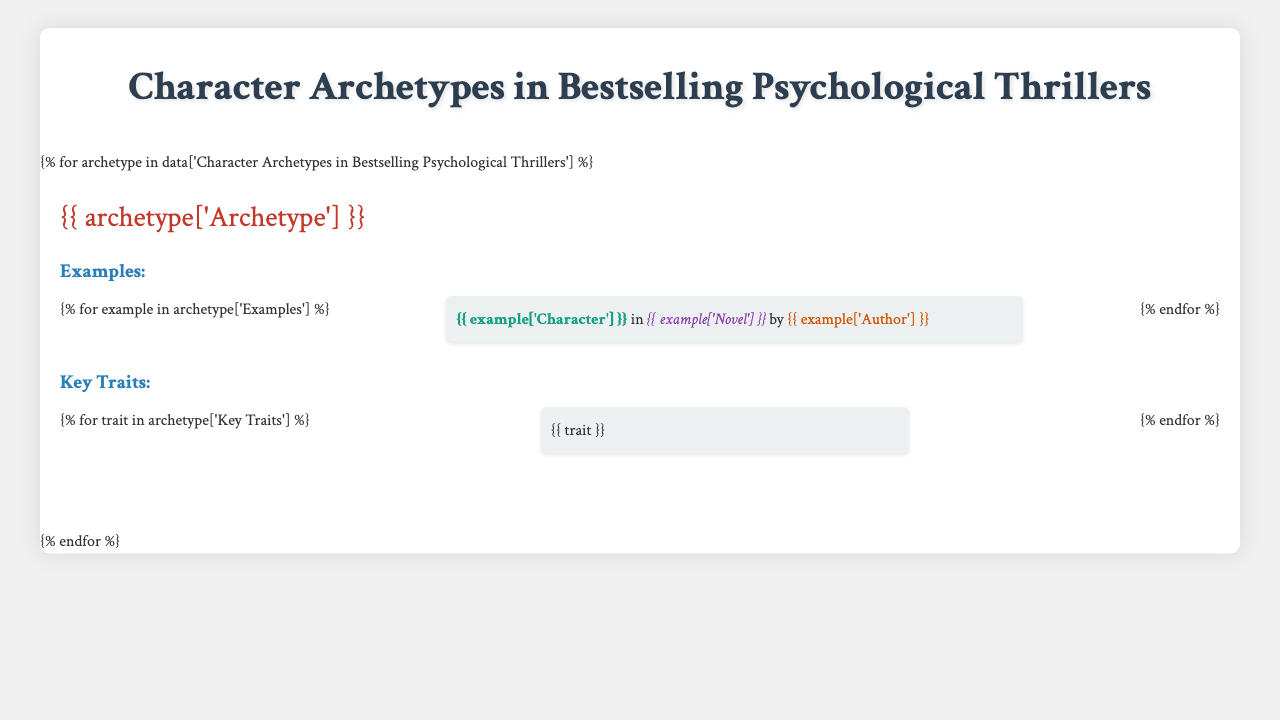What is the archetype represented by Amy Dunne? Amy Dunne is listed under the archetype "The Unreliable Narrator" in the table.
Answer: The Unreliable Narrator Which character exhibits traits of past trauma and an obsessive personality? The character Lisbeth Salander is noted as having both past trauma and an obsessive personality under "The Troubled Detective" archetype.
Answer: Lisbeth Salander How many examples are provided for "The Manipulative Villain"? "The Manipulative Villain" has two examples listed: Tom Ripley and Annie Wilkes. Thus, the total number of examples is two.
Answer: 2 Is Christine Lucas associated with "The Vulnerable Victim"? Yes, Christine Lucas is one of the examples under the "The Vulnerable Victim" archetype, indicating her association.
Answer: Yes Which archetype includes characters with hidden motives? The archetype that features characters with hidden motives is "The Ambiguous Friend."
Answer: The Ambiguous Friend What common trait do both characters in "The Unreliable Narrator" share? Both characters, Rachel Watson and Amy Dunne, share the common trait of having struggles with deceptive behavior.
Answer: Deceptive behavior List the key traits corresponding to "The Manipulative Villain." The key traits for "The Manipulative Villain" include charismatic, sociopathic tendencies, and master of deception.
Answer: Charismatic, sociopathic tendencies, master of deception What is the total number of character archetypes mentioned in the table? There are five archetypes listed in the table, including The Unreliable Narrator, The Troubled Detective, The Manipulative Villain, The Vulnerable Victim, and The Ambiguous Friend.
Answer: 5 Which archetype has a character that is also a target of manipulation? "The Vulnerable Victim" archetype contains characters like Megan Hipwell and Christine Lucas, both of whom are targets of manipulation.
Answer: The Vulnerable Victim Are there more characters in the "The Troubled Detective" archetype or the "The Unreliable Narrator"? Both archetypes have two characters each, so they are equal in numbers. Thus, neither has more characters than the other.
Answer: Equal 